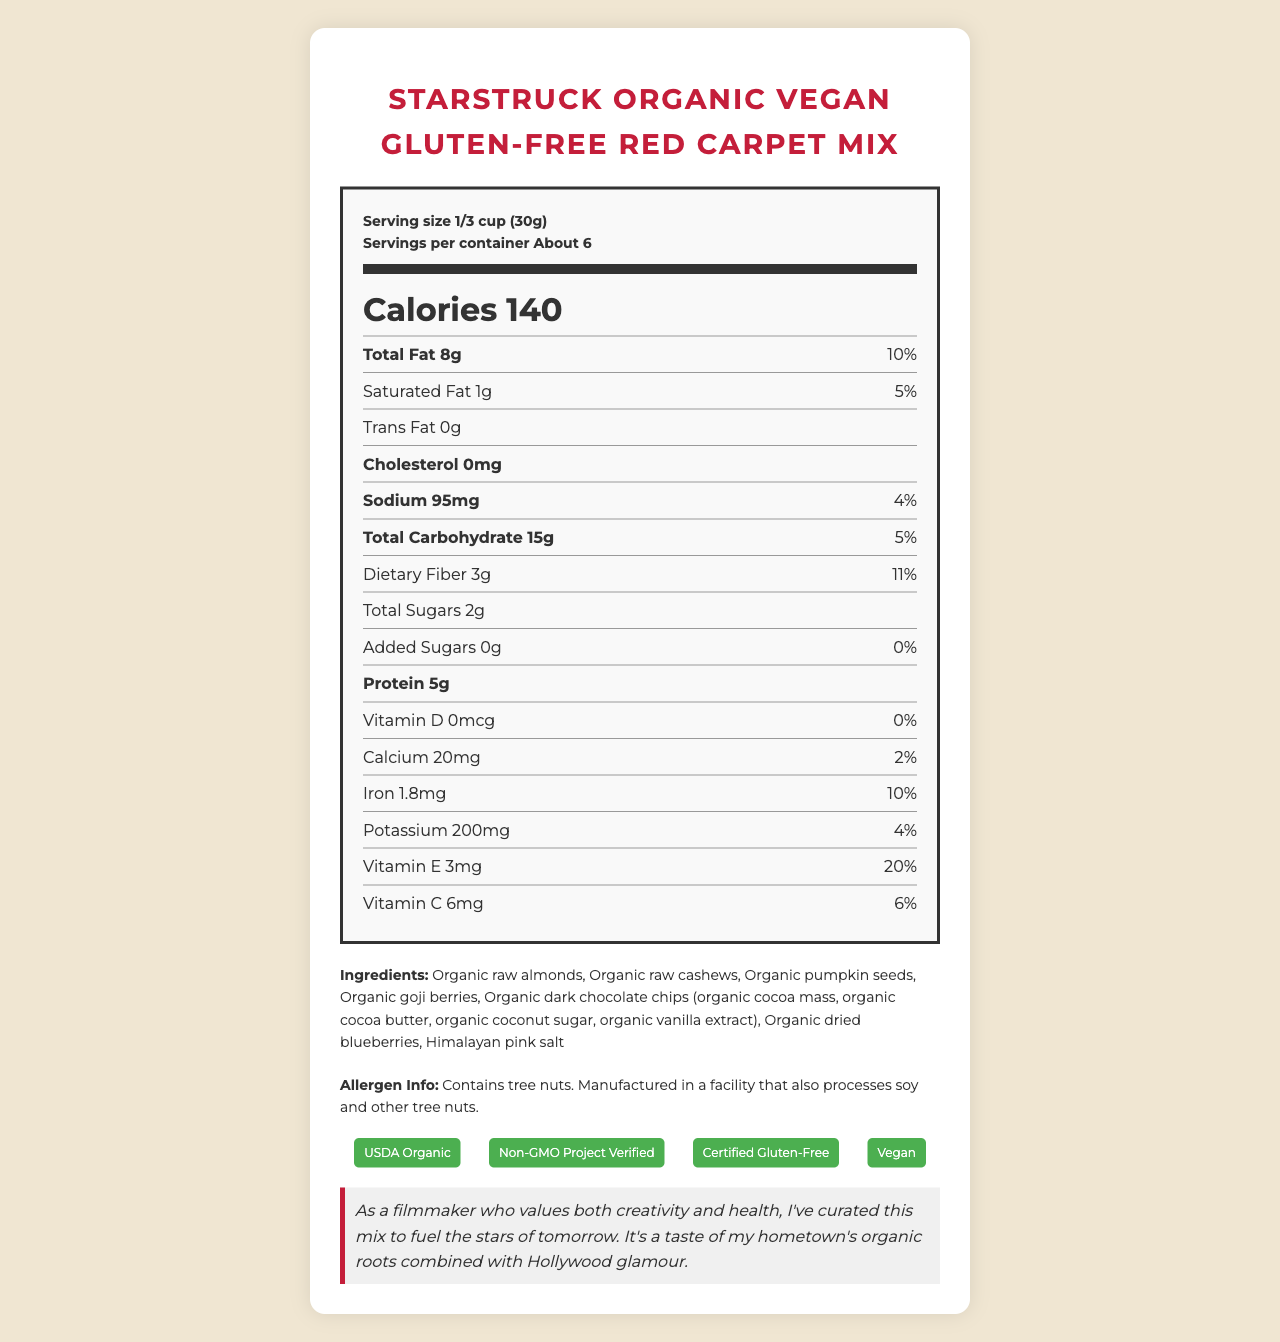what is the serving size? The serving size is listed in the serving information at the top of the Nutrition Facts Label.
Answer: 1/3 cup (30g) how many calories are in one serving? The calories per serving are displayed prominently in the middle of the Nutrition Facts Label.
Answer: 140 what is the total fat content per serving? The total fat content per serving is found in the first row of the nutrient information section.
Answer: 8g how many grams of dietary fiber are there per serving? The dietary fiber can be found under the total carbohydrate section of the label.
Answer: 3g what are the ingredients used in this snack mix? The ingredients list is provided below the nutrient information section in the document.
Answer: Organic raw almonds, Organic raw cashews, Organic pumpkin seeds, Organic goji berries, Organic dark chocolate chips (organic cocoa mass, organic cocoa butter, organic coconut sugar, organic vanilla extract), Organic dried blueberries, Himalayan pink salt which vitamin has the highest daily value percentage? A. Vitamin C B. Vitamin D C. Vitamin E Vitamin E has a daily value of 20%, which is the highest compared to Vitamin C (6%) and Vitamin D (0%).
Answer: C how much sodium does each serving contain? A. 4mg B. 95mg C. 20mg D. 50mg Each serving contains 95mg of sodium, as specified in the sodium section of the Nutrition Facts Label.
Answer: B is this snack mix suitable for vegans? The label has a certification stating it is Vegan and also includes vegan-friendly ingredients.
Answer: Yes does the snack mix contain any trans fat? The trans fat amount is listed as 0g on the Nutrition Facts Label.
Answer: No what claim does the snack mix make about antioxidants? The marketing claims section states that the snack is packed with antioxidants from goji berries, blueberries, and dark chocolate.
Answer: Packed with antioxidants from goji berries, blueberries, and dark chocolate summarize the main features and benefits of the StarStruck Organic Vegan Gluten-Free Red Carpet Mix. The mix is specifically created for an audience that values health and organic ingredients, making it suitable for vegan and gluten-free diets, and it emphasizes antioxidant properties and energy-boosting benefits.
Answer: The StarStruck Organic Vegan Gluten-Free Red Carpet Mix is a healthy snack designed for award show gift bags. It is certified USDA Organic, Non-GMO Project Verified, Certified Gluten-Free, and Vegan. Each serving contains 140 calories, 8g of total fat, 3g of dietary fiber, and 5g of protein. It features ingredients like organic raw almonds, cashews, pumpkin seeds, goji berries, dark chocolate chips, dried blueberries, and Himalayan pink salt. The mix is packed with antioxidants, heart-healthy omega-3 fatty acids, and vitamin E for skin health, with no artificial colors, flavors, or preservatives. It is packaged in an eco-friendly, resealable pouch and designed to maintain energy levels during long award ceremonies. where are the sugar sources for this snack mentioned in the ingredients? The ingredients list mentions these components which are natural sources of sugar.
Answer: Organic goji berries, Organic dark chocolate chips, Organic dried blueberries is there any added sugar in the snack mix? The label states that there are 0g of added sugars per serving.
Answer: No what is the net weight of the snack mix? The net weight is listed at the bottom of the document.
Answer: 6 oz (170g) does the snack mix contain artificial preservatives? The marketing claims state that the snack contains no artificial colors, flavors, or preservatives.
Answer: No who is the intended audience for this snack mix? The director note specifies that the mix is curated to fuel upcoming stars at long award ceremonies.
Answer: Stars of tomorrow, specifically those attending award show ceremonies what is hilal's position in the company? The document doesn't provide any information about anyone named Hilal or their position in the company.
Answer: Cannot be determined 